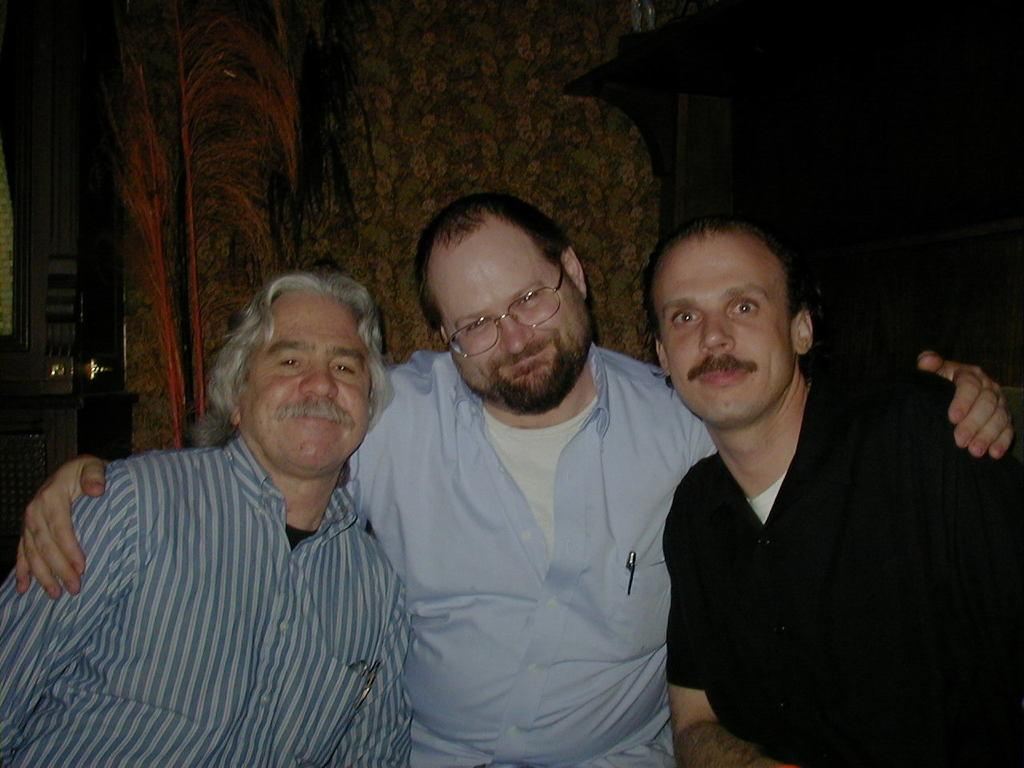How many people are in the image? There are three men in the image. What are the men wearing? The men are wearing clothes. What objects can be seen in the image besides the men? There is a pen and spectacles in the image. What is in the background of the image? There is a wall in the image, and half of the background is blurred. What type of pig can be seen playing in the rain in the image? There is no pig or rain present in the image; it features three men, a pen, spectacles, and a wall. Is there a scarecrow visible in the image? No, there is no scarecrow present in the image. 